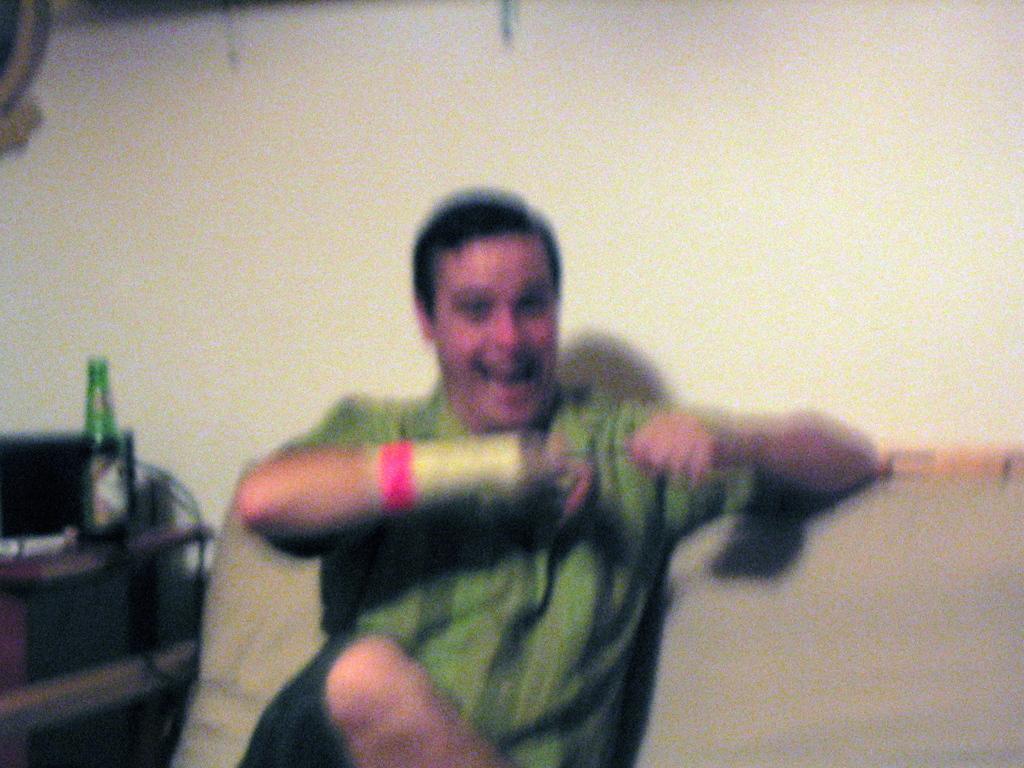How would you summarize this image in a sentence or two? In this image we can see a man wearing green color shirt and sitting on the sofa. In the background we can see the plain wall. On the left there is a green color bottle on the wooden counter. 